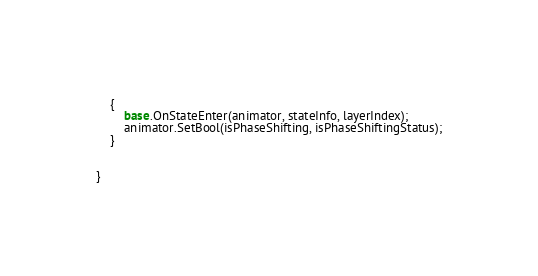<code> <loc_0><loc_0><loc_500><loc_500><_C#_>    {
        base.OnStateEnter(animator, stateInfo, layerIndex);
        animator.SetBool(isPhaseShifting, isPhaseShiftingStatus);
    }


}
</code> 